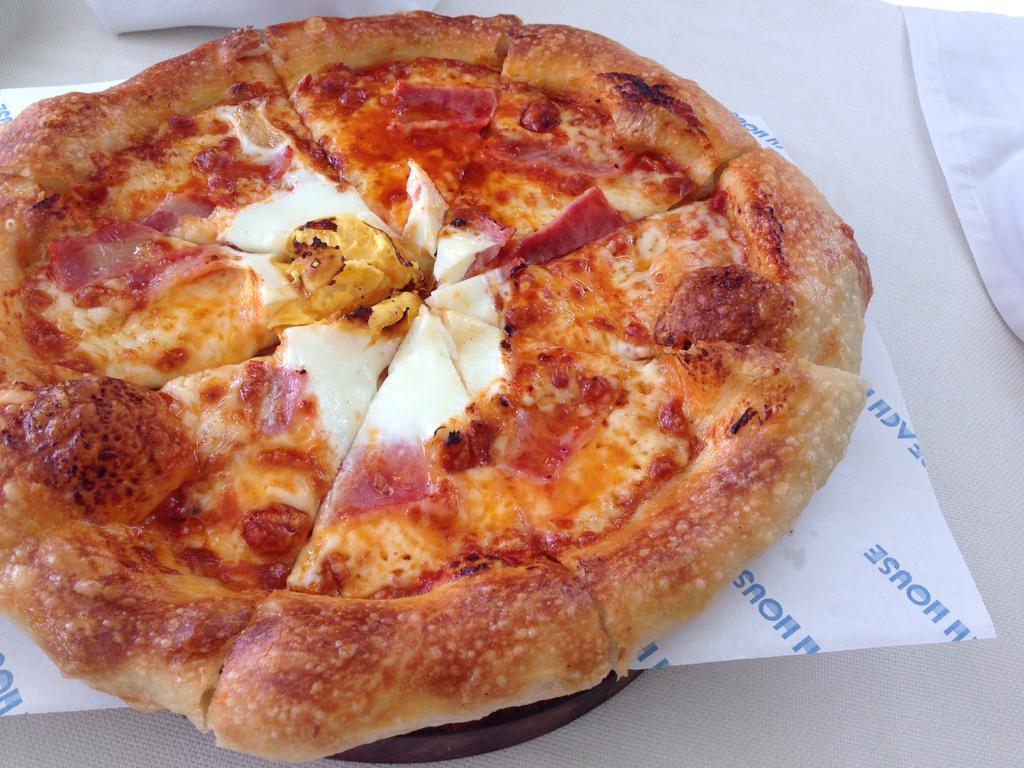Can you describe this image briefly? In this image we can see slices of a pizza on a tissue paper, also we can see some part of the cloth. 